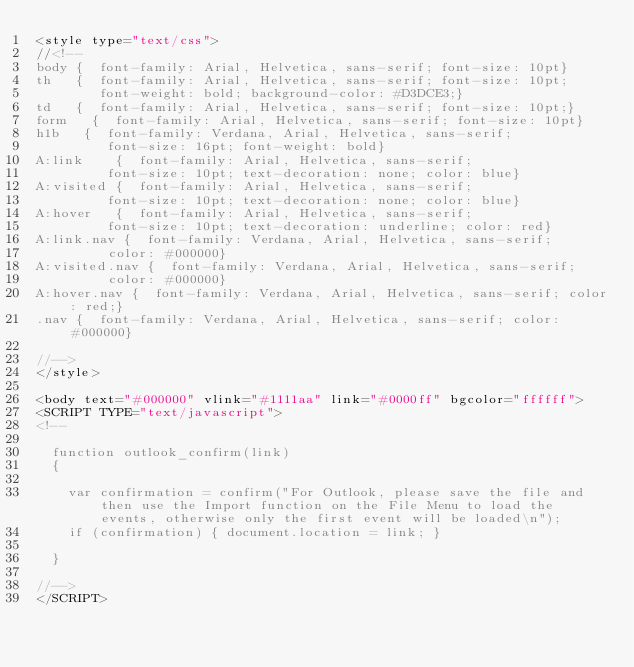<code> <loc_0><loc_0><loc_500><loc_500><_HTML_><style type="text/css">
//<!--
body {  font-family: Arial, Helvetica, sans-serif; font-size: 10pt}
th   {  font-family: Arial, Helvetica, sans-serif; font-size: 10pt; 
        font-weight: bold; background-color: #D3DCE3;}
td   {  font-family: Arial, Helvetica, sans-serif; font-size: 10pt;}
form   {  font-family: Arial, Helvetica, sans-serif; font-size: 10pt}
h1b   {  font-family: Verdana, Arial, Helvetica, sans-serif; 
         font-size: 16pt; font-weight: bold}
A:link    {  font-family: Arial, Helvetica, sans-serif; 
         font-size: 10pt; text-decoration: none; color: blue}
A:visited {  font-family: Arial, Helvetica, sans-serif; 
         font-size: 10pt; text-decoration: none; color: blue}
A:hover   {  font-family: Arial, Helvetica, sans-serif; 
         font-size: 10pt; text-decoration: underline; color: red}
A:link.nav {  font-family: Verdana, Arial, Helvetica, sans-serif; 
         color: #000000}
A:visited.nav {  font-family: Verdana, Arial, Helvetica, sans-serif; 
         color: #000000}
A:hover.nav {  font-family: Verdana, Arial, Helvetica, sans-serif; color: red;}
.nav {  font-family: Verdana, Arial, Helvetica, sans-serif; color: #000000}

//-->
</style>

<body text="#000000" vlink="#1111aa" link="#0000ff" bgcolor="ffffff">
<SCRIPT TYPE="text/javascript">
<!--

  function outlook_confirm(link)
  {

    var confirmation = confirm("For Outlook, please save the file and then use the Import function on the File Menu to load the events, otherwise only the first event will be loaded\n");
    if (confirmation) { document.location = link; }                                 

  }

//-->
</SCRIPT>






</code> 